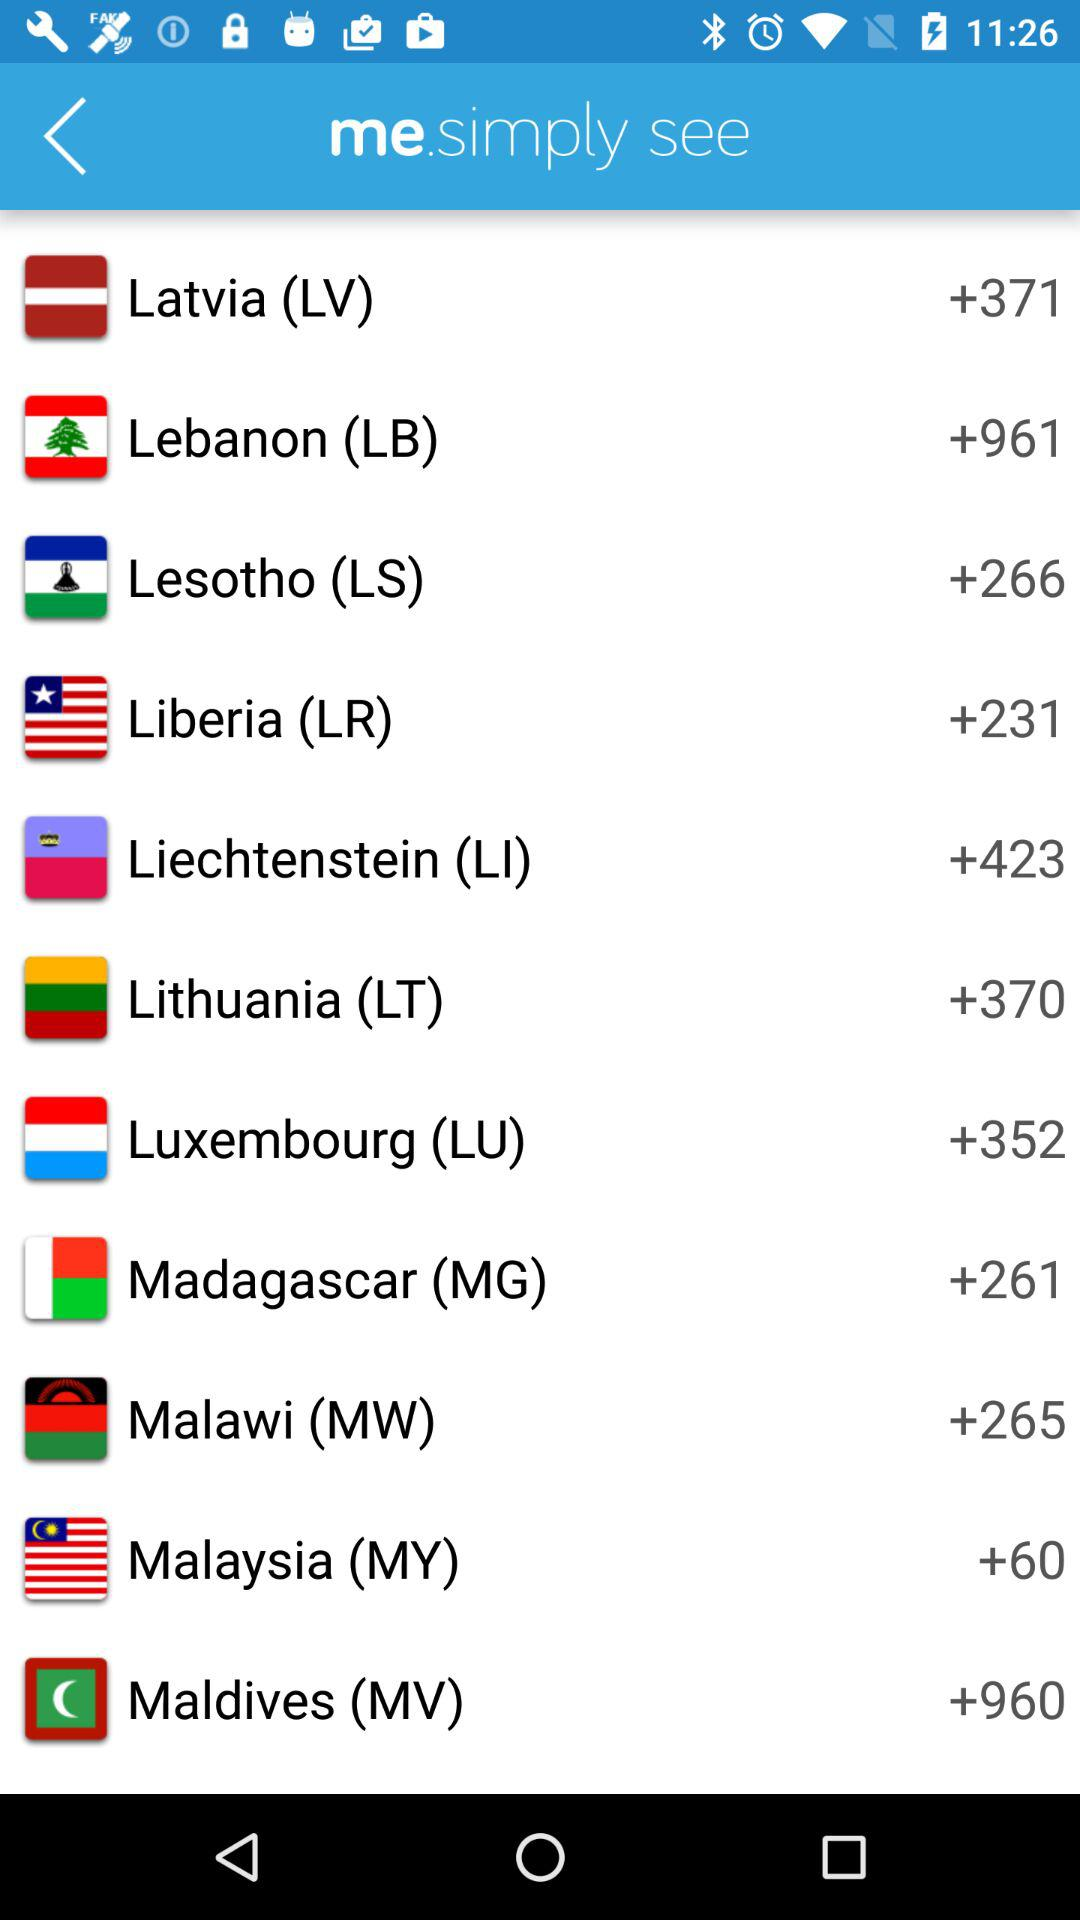What is the code of Maldives? The code of Maldives is +960. 